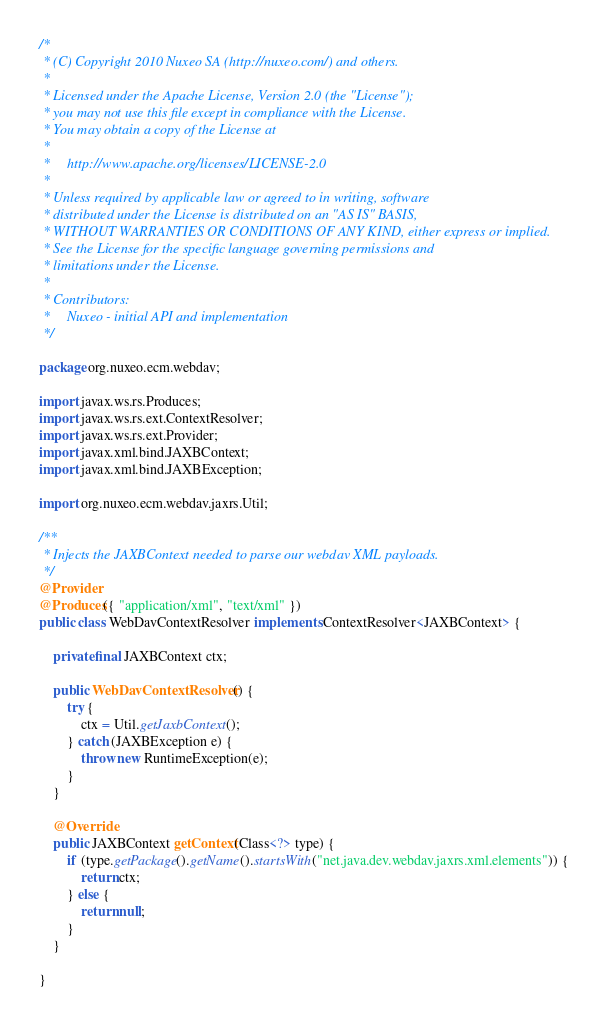<code> <loc_0><loc_0><loc_500><loc_500><_Java_>/*
 * (C) Copyright 2010 Nuxeo SA (http://nuxeo.com/) and others.
 *
 * Licensed under the Apache License, Version 2.0 (the "License");
 * you may not use this file except in compliance with the License.
 * You may obtain a copy of the License at
 *
 *     http://www.apache.org/licenses/LICENSE-2.0
 *
 * Unless required by applicable law or agreed to in writing, software
 * distributed under the License is distributed on an "AS IS" BASIS,
 * WITHOUT WARRANTIES OR CONDITIONS OF ANY KIND, either express or implied.
 * See the License for the specific language governing permissions and
 * limitations under the License.
 *
 * Contributors:
 *     Nuxeo - initial API and implementation
 */

package org.nuxeo.ecm.webdav;

import javax.ws.rs.Produces;
import javax.ws.rs.ext.ContextResolver;
import javax.ws.rs.ext.Provider;
import javax.xml.bind.JAXBContext;
import javax.xml.bind.JAXBException;

import org.nuxeo.ecm.webdav.jaxrs.Util;

/**
 * Injects the JAXBContext needed to parse our webdav XML payloads.
 */
@Provider
@Produces({ "application/xml", "text/xml" })
public class WebDavContextResolver implements ContextResolver<JAXBContext> {

    private final JAXBContext ctx;

    public WebDavContextResolver() {
        try {
            ctx = Util.getJaxbContext();
        } catch (JAXBException e) {
            throw new RuntimeException(e);
        }
    }

    @Override
    public JAXBContext getContext(Class<?> type) {
        if (type.getPackage().getName().startsWith("net.java.dev.webdav.jaxrs.xml.elements")) {
            return ctx;
        } else {
            return null;
        }
    }

}
</code> 